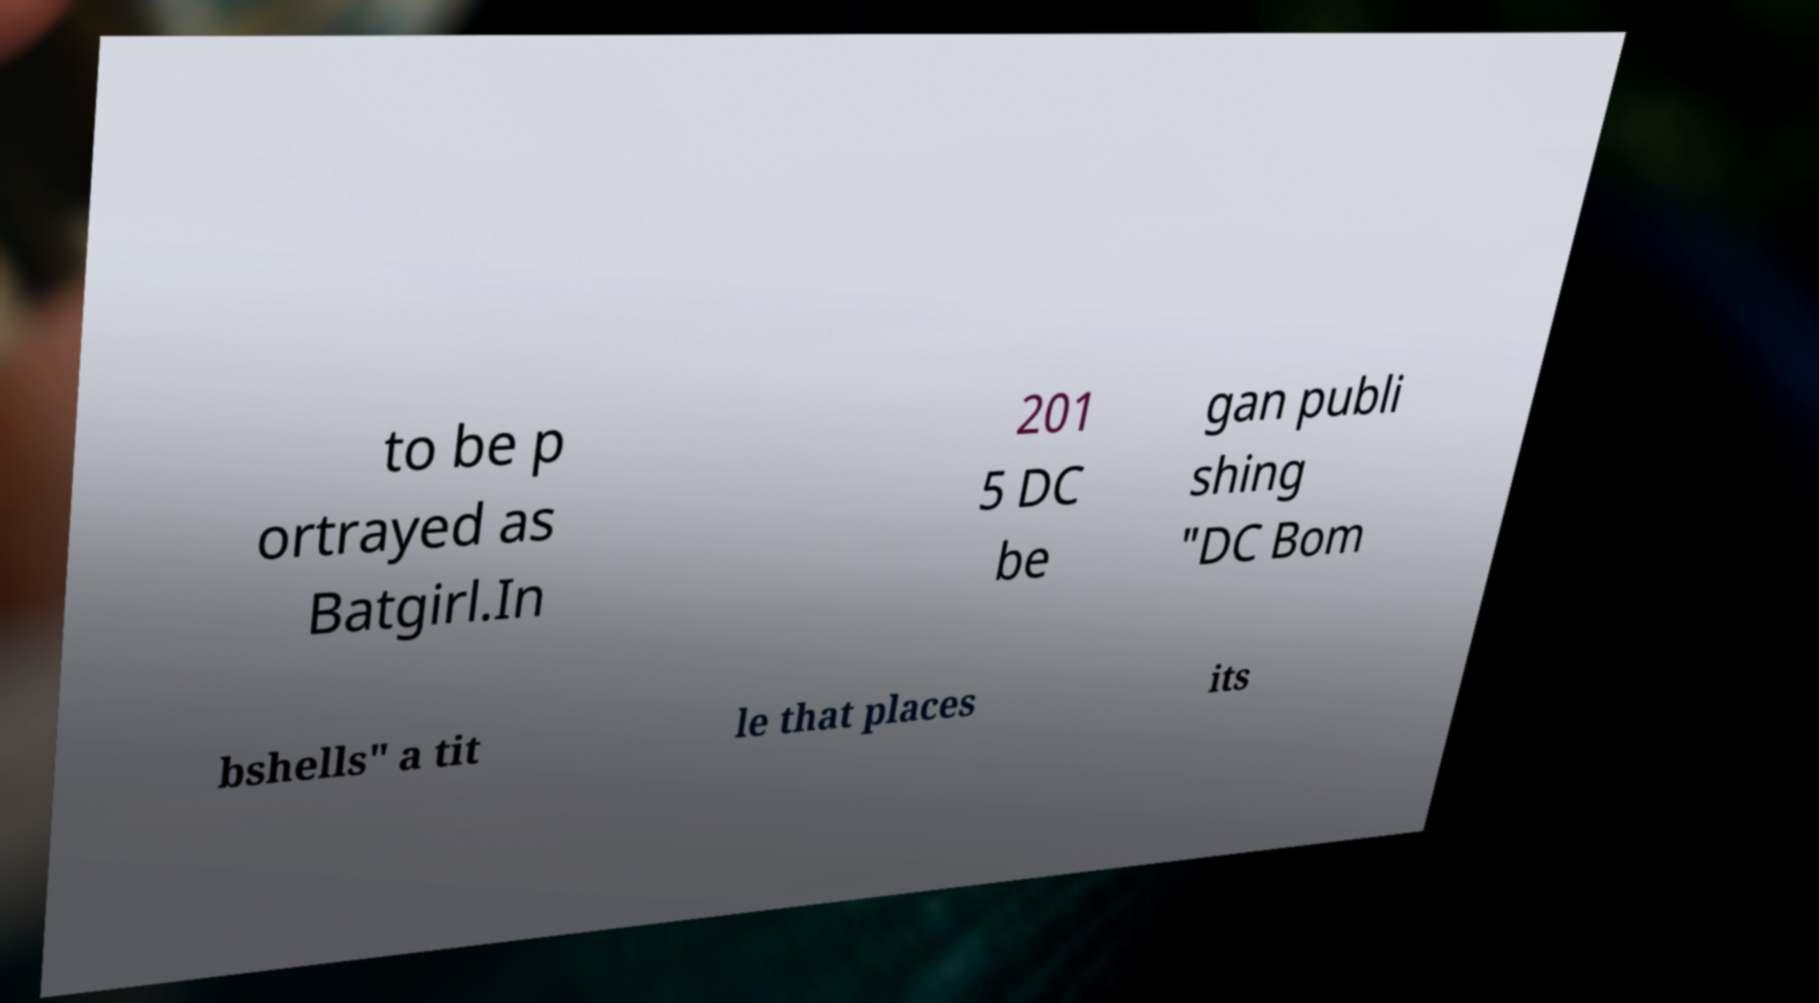I need the written content from this picture converted into text. Can you do that? to be p ortrayed as Batgirl.In 201 5 DC be gan publi shing "DC Bom bshells" a tit le that places its 